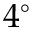<formula> <loc_0><loc_0><loc_500><loc_500>4 ^ { \circ }</formula> 